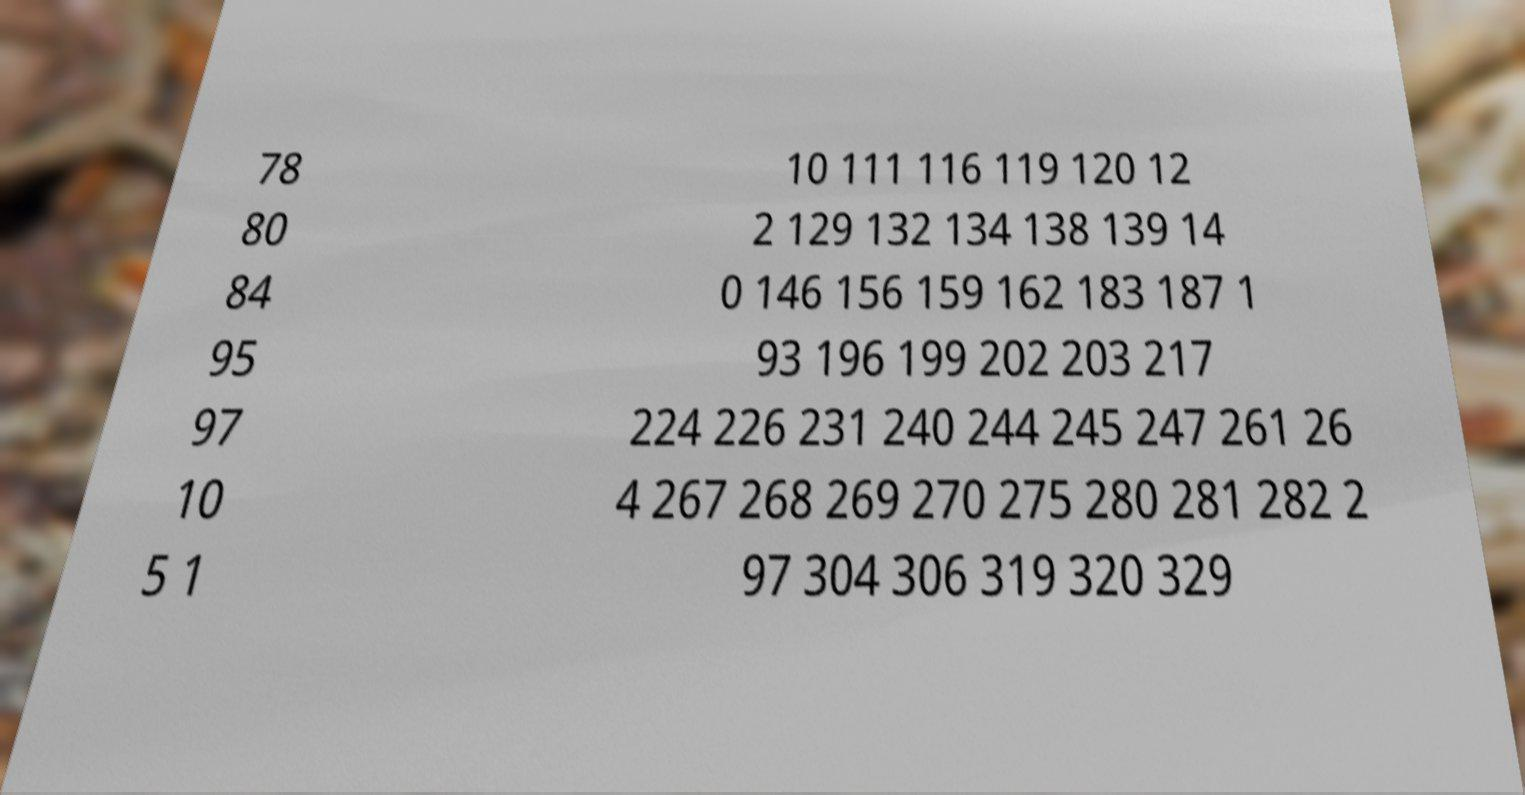There's text embedded in this image that I need extracted. Can you transcribe it verbatim? 78 80 84 95 97 10 5 1 10 111 116 119 120 12 2 129 132 134 138 139 14 0 146 156 159 162 183 187 1 93 196 199 202 203 217 224 226 231 240 244 245 247 261 26 4 267 268 269 270 275 280 281 282 2 97 304 306 319 320 329 